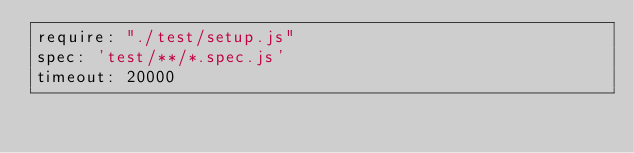Convert code to text. <code><loc_0><loc_0><loc_500><loc_500><_YAML_>require: "./test/setup.js"
spec: 'test/**/*.spec.js'
timeout: 20000
</code> 